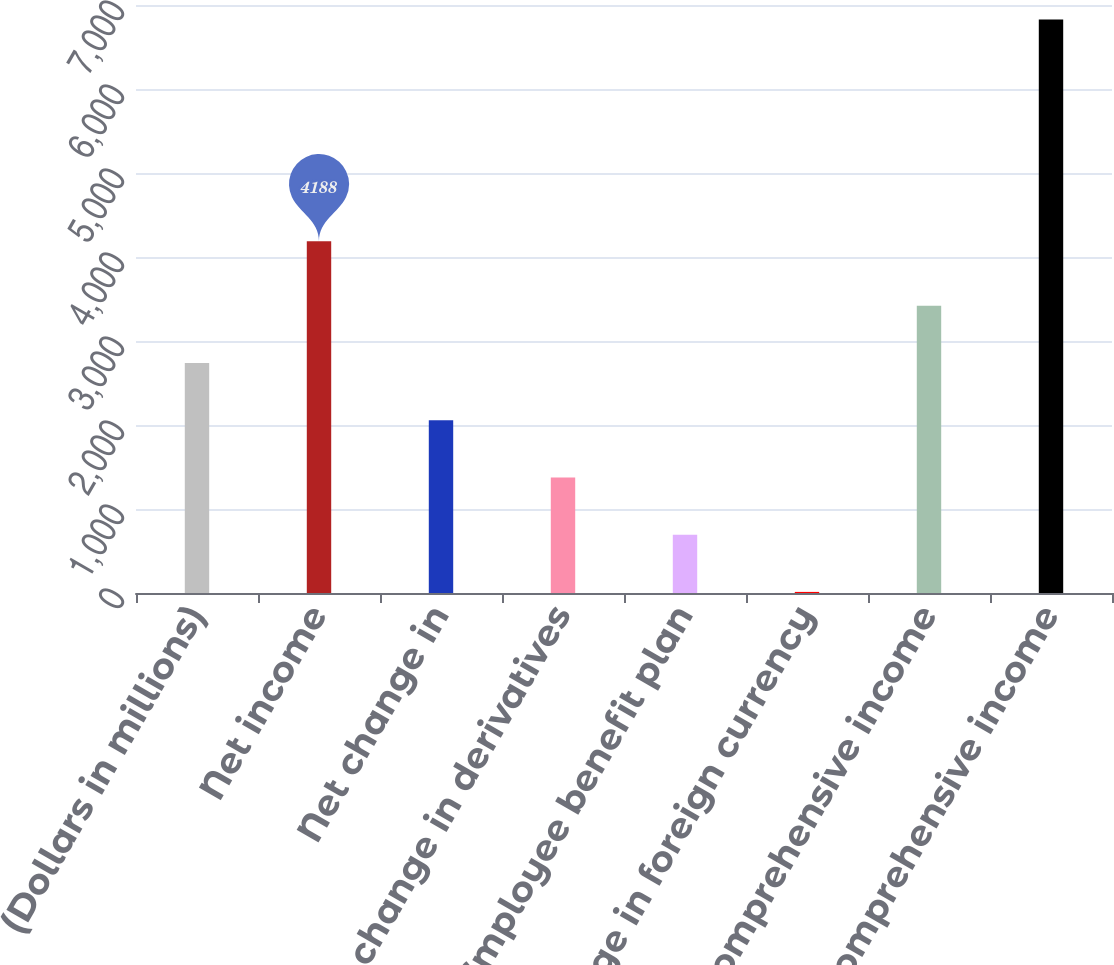Convert chart to OTSL. <chart><loc_0><loc_0><loc_500><loc_500><bar_chart><fcel>(Dollars in millions)<fcel>Net income<fcel>Net change in<fcel>Net change in derivatives<fcel>Employee benefit plan<fcel>Net change in foreign currency<fcel>Other comprehensive income<fcel>Comprehensive income<nl><fcel>2739<fcel>4188<fcel>2057.5<fcel>1376<fcel>694.5<fcel>13<fcel>3420.5<fcel>6828<nl></chart> 